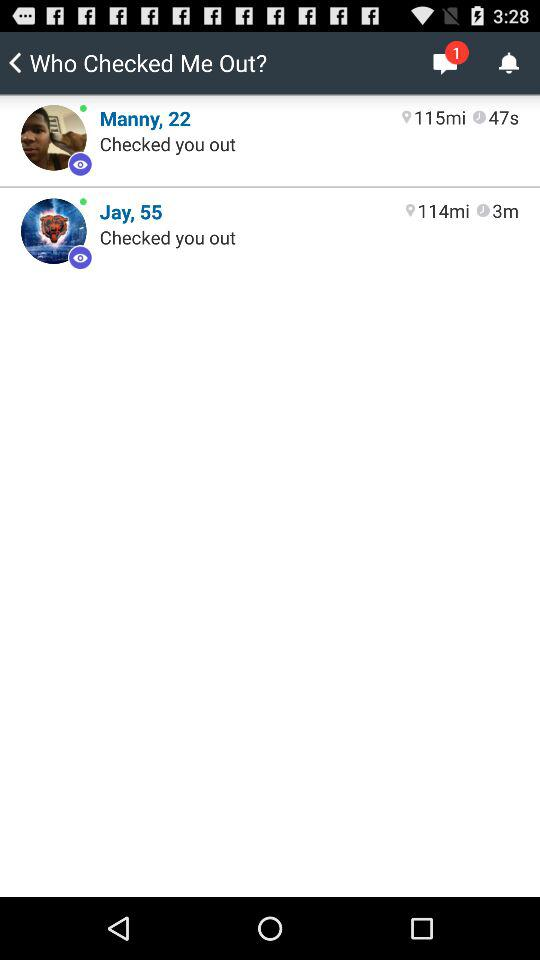Who checked me out more recently, Manny or Jay?
Answer the question using a single word or phrase. Jay 